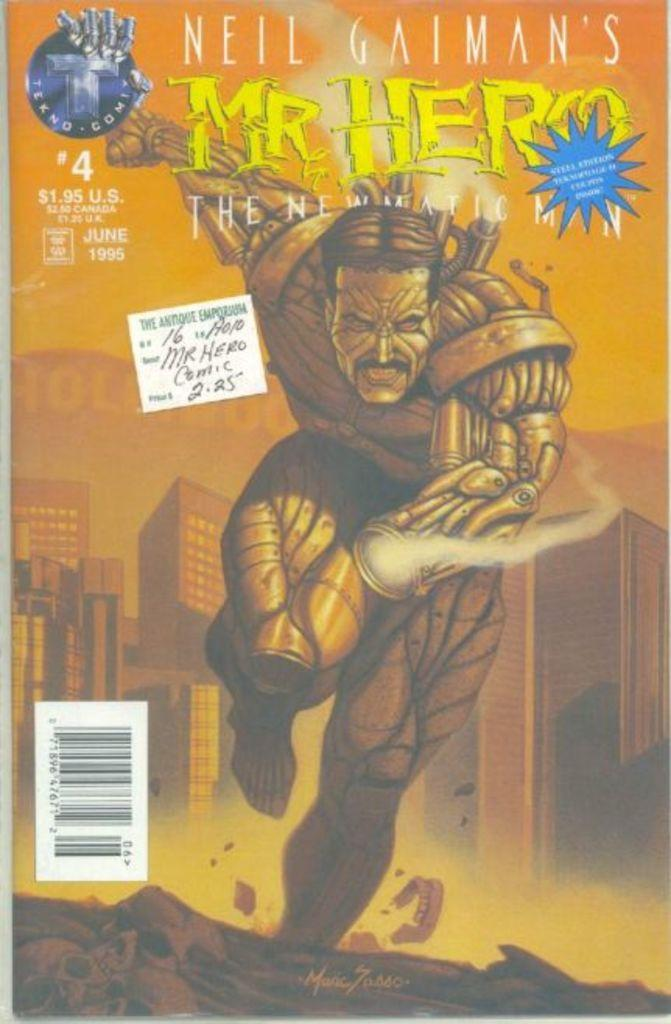<image>
Provide a brief description of the given image. The cover of the comic book of Neil Gaiman's Mr. Hero. 